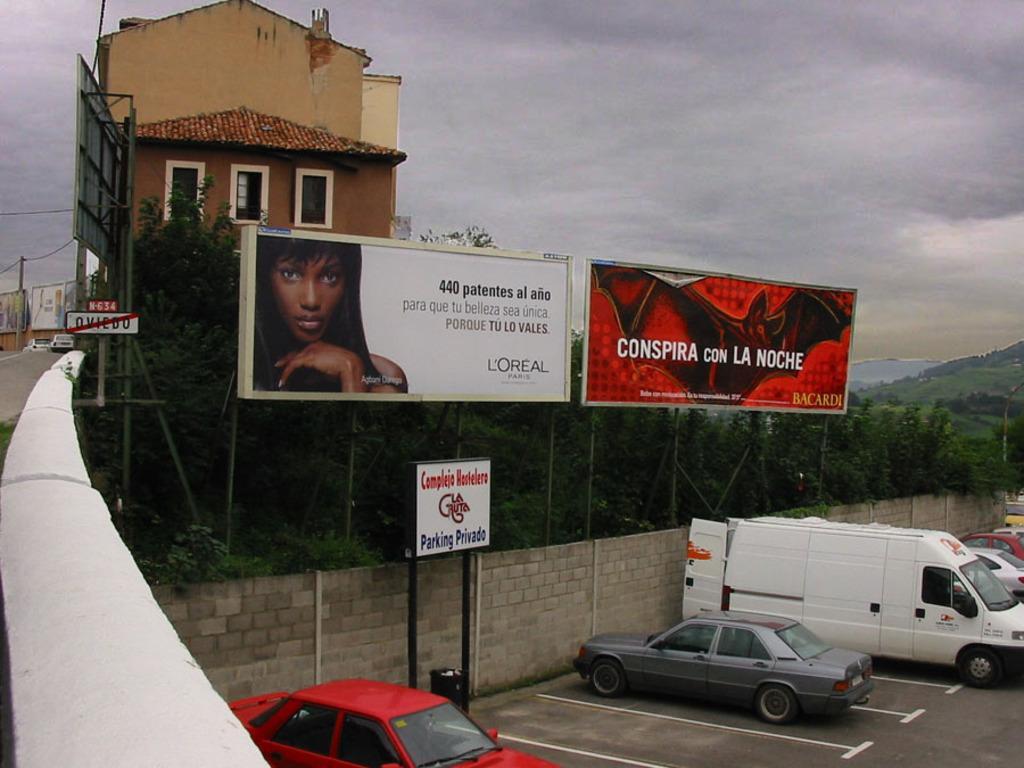Please provide a concise description of this image. On the left side of the image we can see a house, a board and some trees. In the middle of the image we can see a board and cars which are parked. On the right side of the image we can see trees, water body and a van. 